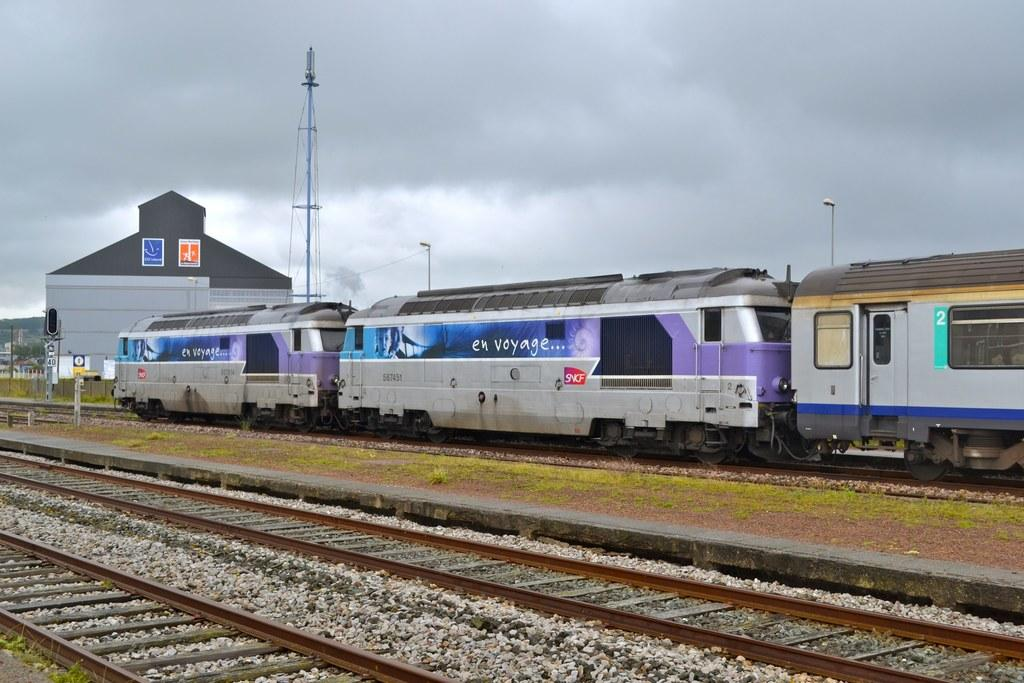What type of transportation can be seen in the image? There is a train in the image. What is located in front of the train? There is grass in front of the train. What structures are visible in the background of the image? There is a building, a tower, and two poles in the background of the image. What is the condition of the sky in the image? The sky is visible in the background of the image, and it appears to be cloudy. Can you see any clover growing near the train in the image? There is no clover visible in the image; the area in front of the train is covered with grass. 